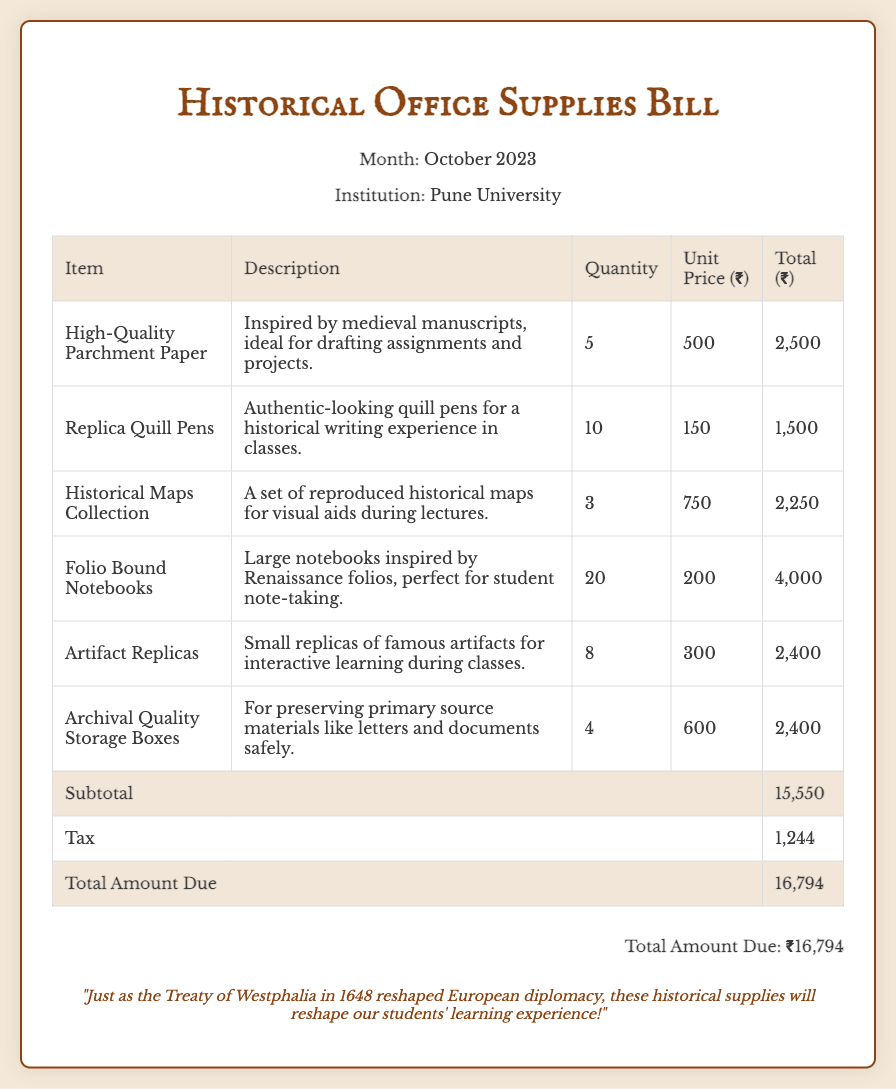What is the month of this bill? The document specifies that the bill is for the month of October 2023.
Answer: October 2023 How many Replica Quill Pens were purchased? The document lists that 10 Replica Quill Pens were purchased.
Answer: 10 What is the total amount due? The document shows the total amount due is ₹16,794.
Answer: ₹16,794 What is the unit price of Historical Maps Collection? The unit price for the Historical Maps Collection is listed as ₹750.
Answer: ₹750 What is the subtotal of the items before tax? The subtotal before tax is shown as ₹15,550 in the document.
Answer: ₹15,550 How many Artifact Replicas were bought? The document states that 8 Artifact Replicas were bought.
Answer: 8 What item is used for preserving primary source materials? The document mentions "Archival Quality Storage Boxes" for preserving primary source materials.
Answer: Archival Quality Storage Boxes What historical concept is referenced in the note at the bottom? The note references the "Treaty of Westphalia" as a historical concept.
Answer: Treaty of Westphalia What is the price for High-Quality Parchment Paper? The price for High-Quality Parchment Paper is listed as ₹500.
Answer: ₹500 